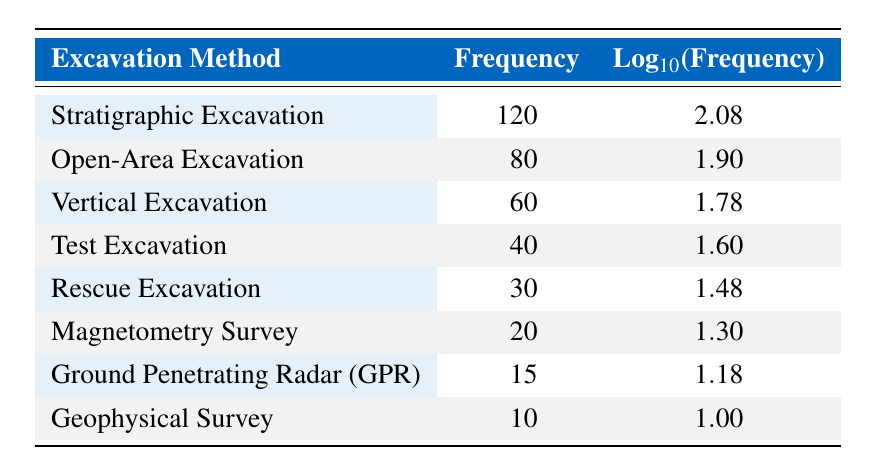What is the frequency of Stratigraphic Excavation? The table states the frequency for Stratigraphic Excavation as 120.
Answer: 120 Which excavation method has the lowest frequency? By examining the frequencies listed, the method with the lowest frequency is Geophysical Survey, which has a frequency of 10.
Answer: Geophysical Survey What is the difference in frequency between Open-Area Excavation and Vertical Excavation? The frequency of Open-Area Excavation is 80 and the frequency of Vertical Excavation is 60. The difference is calculated as 80 - 60 = 20.
Answer: 20 Is the frequency of Rescue Excavation greater than that of Magnetometry Survey? The frequency for Rescue Excavation is 30, and for Magnetometry Survey, it is 20. Since 30 is greater than 20, the statement is true.
Answer: Yes What is the average frequency of the first three excavation methods listed? The first three methods are Stratigraphic Excavation (120), Open-Area Excavation (80), and Vertical Excavation (60). The average is (120 + 80 + 60) / 3 = 260 / 3 ≈ 86.67.
Answer: 86.67 What is the total frequency of all excavation methods combined? Adding up all the frequencies gives us 120 + 80 + 60 + 40 + 30 + 20 + 15 + 10 = 415.
Answer: 415 Which excavation method's frequency is closest to 25? The closest frequency to 25 listed in the table is that of Magnetometry Survey, which is 20.
Answer: Magnetometry Survey How many excavation methods have a frequency of 50 or greater? The methods with frequencies of 50 or greater are Stratigraphic Excavation (120), Open-Area Excavation (80), Vertical Excavation (60), and Test Excavation (40). This totals four methods.
Answer: 4 What is the log value for the frequency of Ground Penetrating Radar? The table indicates that the logarithmic value for Ground Penetrating Radar is 1.18.
Answer: 1.18 